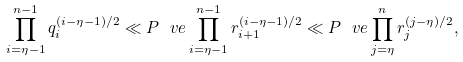Convert formula to latex. <formula><loc_0><loc_0><loc_500><loc_500>\prod _ { i = \eta - 1 } ^ { n - 1 } q _ { i } ^ { ( i - \eta - 1 ) / 2 } \ll P ^ { \ } v e \prod _ { i = \eta - 1 } ^ { n - 1 } r _ { i + 1 } ^ { ( i - \eta - 1 ) / 2 } \ll P ^ { \ } v e \prod _ { j = \eta } ^ { n } r _ { j } ^ { ( j - \eta ) / 2 } ,</formula> 